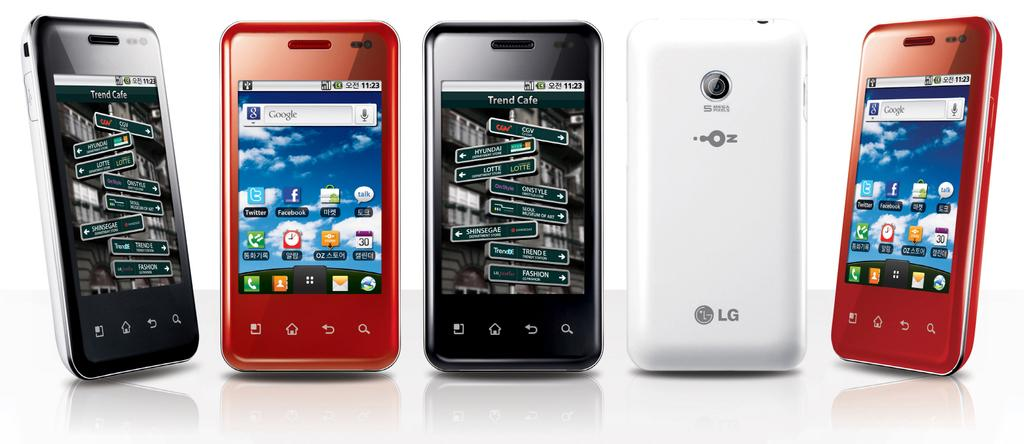Provide a one-sentence caption for the provided image. Five LG smartphones are lined up, all but one facing forward. 